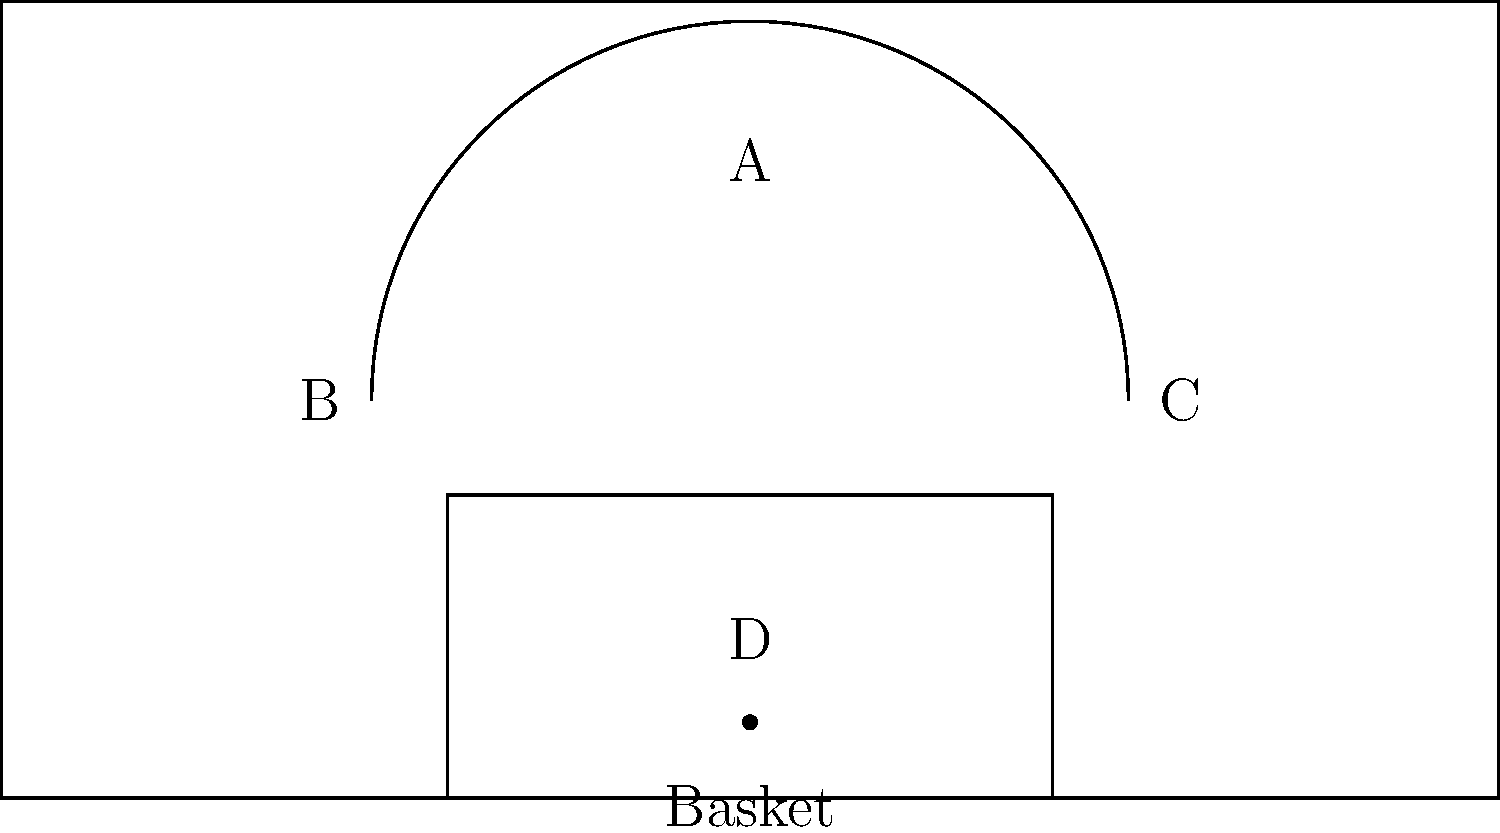Based on the basketball court layout shown, which zone (A, B, C, or D) would you consider the most efficient scoring area for your team, assuming you have a balanced mix of shooters and post players? To determine the most efficient scoring area, we need to consider several factors:

1. Zone A: This area is beyond the three-point line. While three-pointers are worth more points, they typically have a lower success rate.

2. Zones B and C: These areas are inside the three-point line but outside the key. They offer mid-range shots, which can be efficient for skilled shooters but generally have a lower points-per-attempt ratio compared to other areas.

3. Zone D: This area is inside the key, close to the basket. It offers the highest percentage shots (layups, dunks, and close-range post moves) but is also the most heavily defended area.

Given that the team has a balanced mix of shooters and post players:

1. Zone D offers the highest percentage shots and is ideal for post players. It also creates opportunities for offensive rebounds and fouls.

2. The close proximity to the basket in Zone D allows for quick putbacks and second-chance points.

3. While Zone D may be more crowded, having shooters spread out in other zones can create spacing and open up opportunities in Zone D.

4. Shots taken in Zone D, even if missed, often lead to free throws, which are high-percentage scoring opportunities.

5. The threat of scoring in Zone D can draw defenders in, potentially opening up opportunities for shooters in other zones.

Considering these factors, Zone D would likely be the most efficient scoring area for a balanced team, as it offers the highest percentage shots and creates opportunities for both post players and perimeter players.
Answer: Zone D 